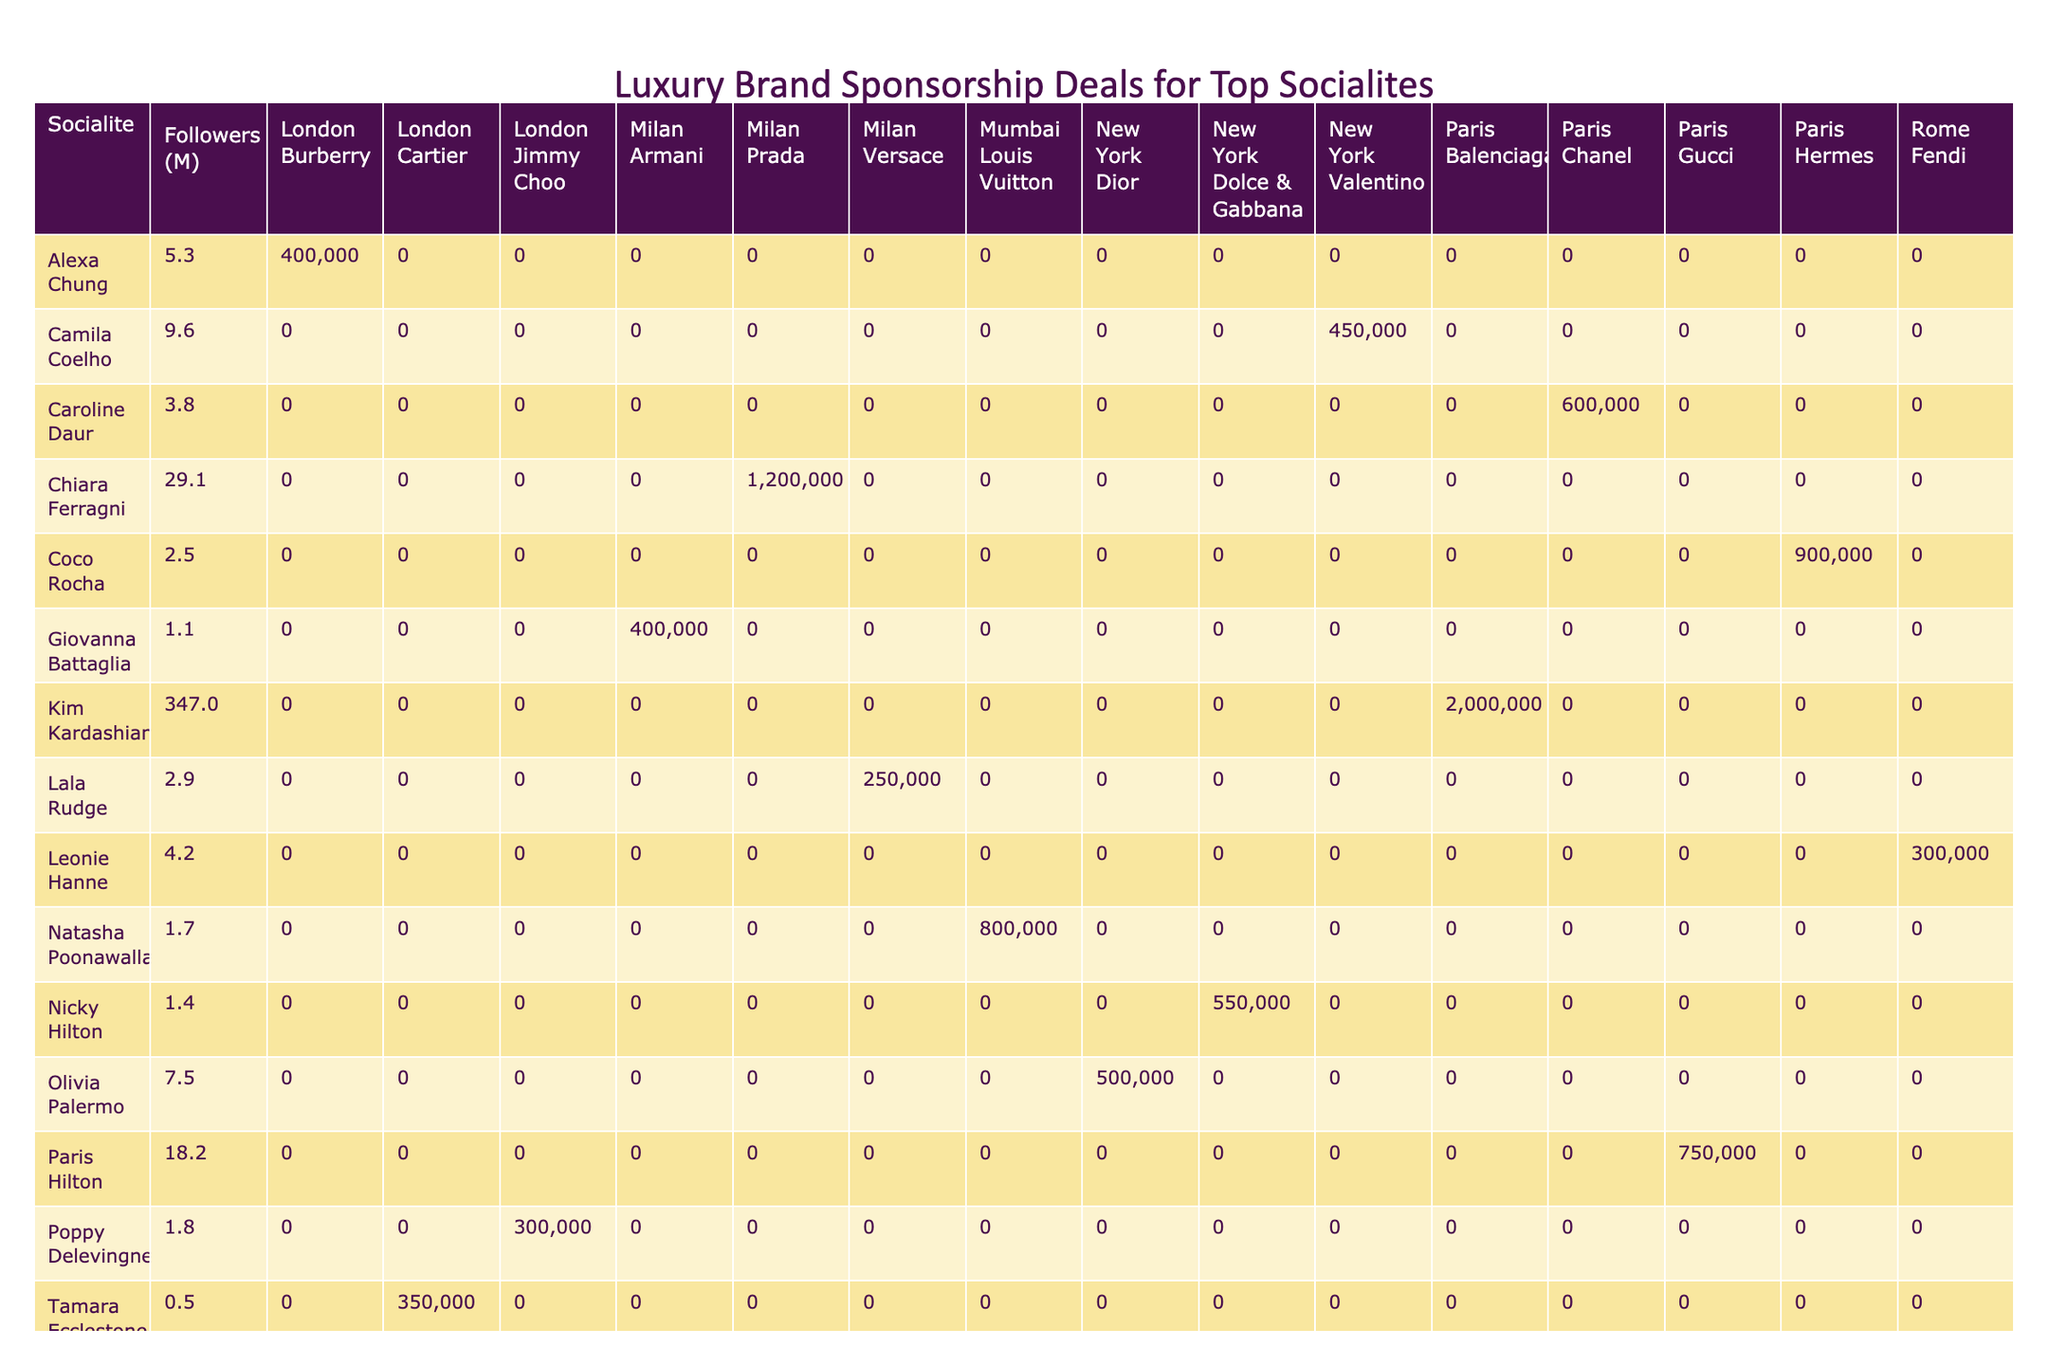What is the highest sponsorship value listed in the table? The table shows various sponsorship values for different socialites. Scanning the sponsorship values, the highest amount listed is 2000000, attributed to Kim Kardashian with Balenciaga.
Answer: 2000000 Which socialite has the most social media followers? By inspecting the followers' column, Kim Kardashian has the highest number of social media followers at 347.0 million.
Answer: 347.0 What is the total sponsorship value for socialites in Paris? The total sponsorship value for Paris can be calculated by adding the values for Paris Hilton (750000), Kim Kardashian (2000000), Caroline Daur (600000), and Coco Rocha (900000). The sum is 750000 + 2000000 + 600000 + 900000 = 4350000.
Answer: 4350000 Is Natasha Poonawalla's sponsorship value higher than that of Camila Coelho? Natasha Poonawalla has a sponsorship value of 800000, whereas Camila Coelho has a value of 450000. Since 800000 is greater than 450000, the answer is yes.
Answer: Yes What is the average sponsorship value for socialites in Milan? The table lists three sponsorship values for socialites in Milan: Chiara Ferragni (1200000), Lala Rudge (250000), and Giovanna Battaglia (400000). The average is calculated as (1200000 + 250000 + 400000) / 3 = 450000.
Answer: 450000 Which event type has the lowest sponsorship value, and who is associated with it? By examining the event types, the lowest sponsorship value is 250000, associated with Lala Rudge for the Fashion Week.
Answer: 250000 (Lala Rudge) What is the difference between the highest and lowest sponsorship values in the table? The highest sponsorship value is 2000000 (Kim Kardashian), and the lowest is 250000 (Lala Rudge). The difference is calculated as 2000000 - 250000 = 1750000.
Answer: 1750000 How many months does Chiara Ferragni's deal last compared to the average duration of all socialites? Chiara Ferragni’s sponsorship lasts for 12 months. The average duration is calculated by summing all durations (6 + 3 + 12 + 4 + 1 + 2 + 9 + 3 + 6 + 4 + 8 + 12 + 3 + 9 + 5) =  66 months over 15 socialites, resulting in an average of 66 / 15 = 4.4 months. Comparatively, 12 months is significantly longer than the average.
Answer: 12 months (longer than average of 4.4 months) 